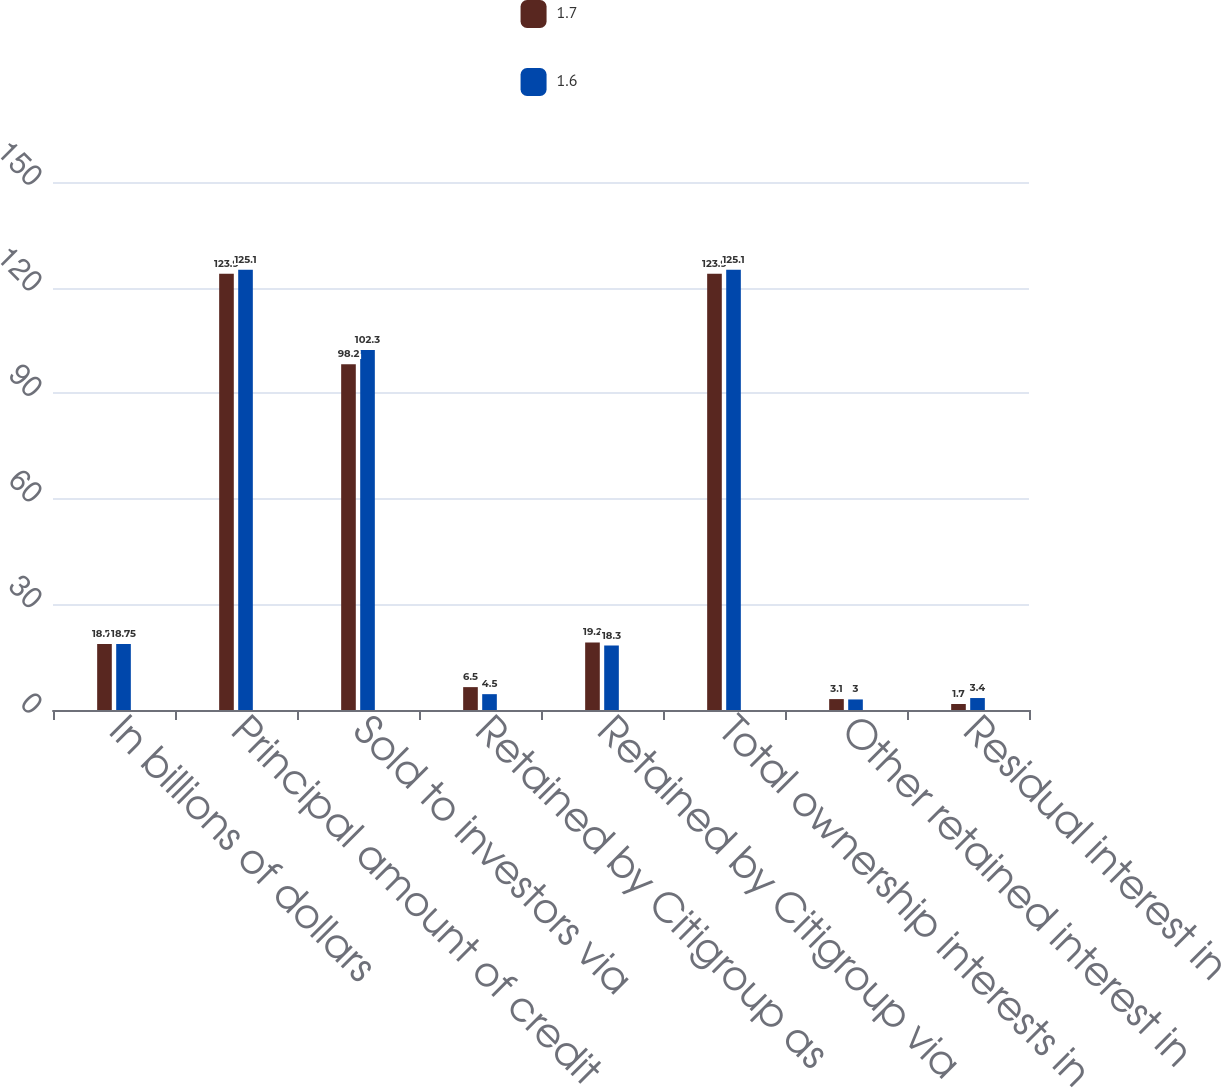<chart> <loc_0><loc_0><loc_500><loc_500><stacked_bar_chart><ecel><fcel>In billions of dollars<fcel>Principal amount of credit<fcel>Sold to investors via<fcel>Retained by Citigroup as<fcel>Retained by Citigroup via<fcel>Total ownership interests in<fcel>Other retained interest in<fcel>Residual interest in<nl><fcel>1.7<fcel>18.75<fcel>123.9<fcel>98.2<fcel>6.5<fcel>19.2<fcel>123.9<fcel>3.1<fcel>1.7<nl><fcel>1.6<fcel>18.75<fcel>125.1<fcel>102.3<fcel>4.5<fcel>18.3<fcel>125.1<fcel>3<fcel>3.4<nl></chart> 